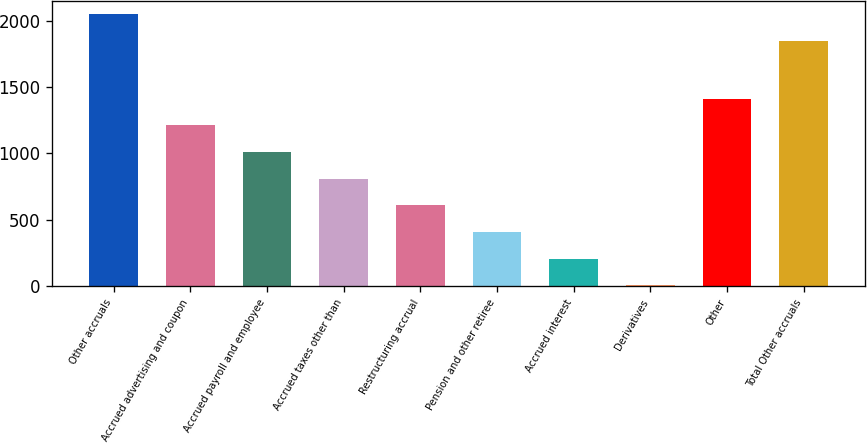Convert chart to OTSL. <chart><loc_0><loc_0><loc_500><loc_500><bar_chart><fcel>Other accruals<fcel>Accrued advertising and coupon<fcel>Accrued payroll and employee<fcel>Accrued taxes other than<fcel>Restructuring accrual<fcel>Pension and other retiree<fcel>Accrued interest<fcel>Derivatives<fcel>Other<fcel>Total Other accruals<nl><fcel>2046<fcel>1211<fcel>1010<fcel>809<fcel>608<fcel>407<fcel>206<fcel>5<fcel>1412<fcel>1845<nl></chart> 